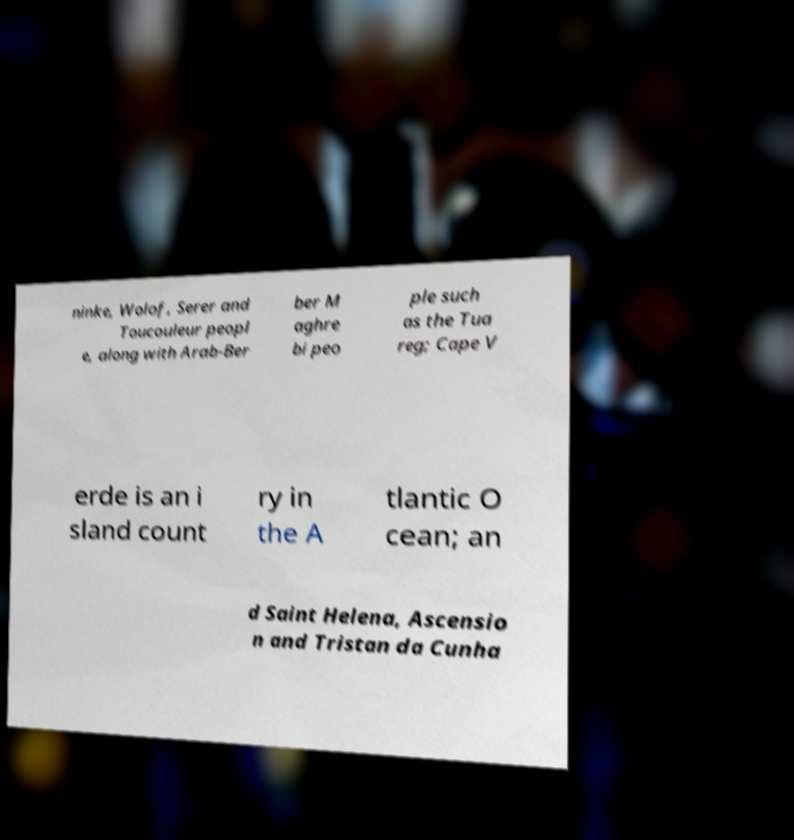Please identify and transcribe the text found in this image. ninke, Wolof, Serer and Toucouleur peopl e, along with Arab-Ber ber M aghre bi peo ple such as the Tua reg; Cape V erde is an i sland count ry in the A tlantic O cean; an d Saint Helena, Ascensio n and Tristan da Cunha 